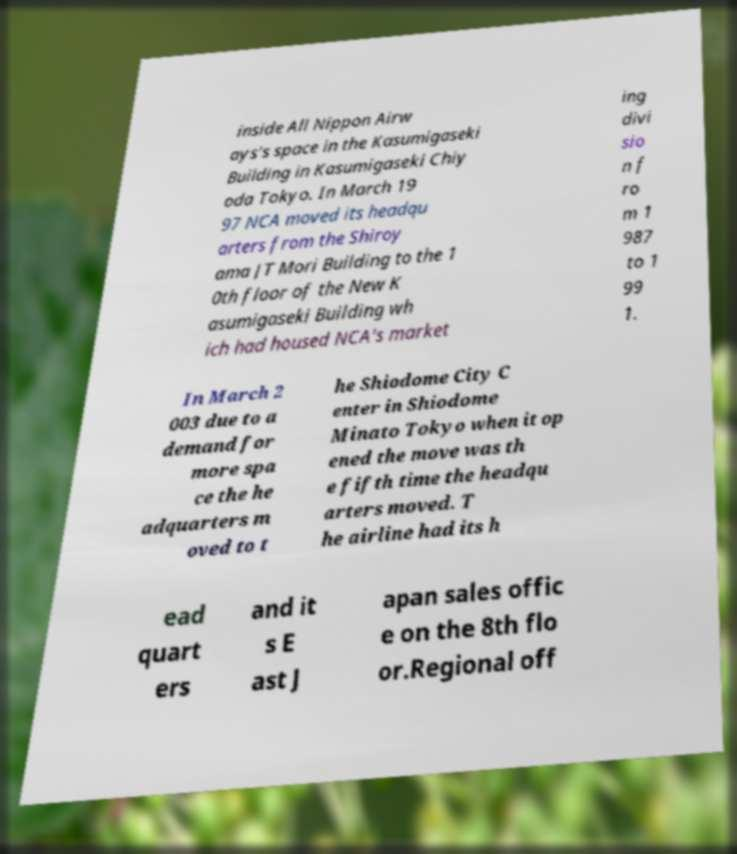For documentation purposes, I need the text within this image transcribed. Could you provide that? inside All Nippon Airw ays's space in the Kasumigaseki Building in Kasumigaseki Chiy oda Tokyo. In March 19 97 NCA moved its headqu arters from the Shiroy ama JT Mori Building to the 1 0th floor of the New K asumigaseki Building wh ich had housed NCA's market ing divi sio n f ro m 1 987 to 1 99 1. In March 2 003 due to a demand for more spa ce the he adquarters m oved to t he Shiodome City C enter in Shiodome Minato Tokyo when it op ened the move was th e fifth time the headqu arters moved. T he airline had its h ead quart ers and it s E ast J apan sales offic e on the 8th flo or.Regional off 